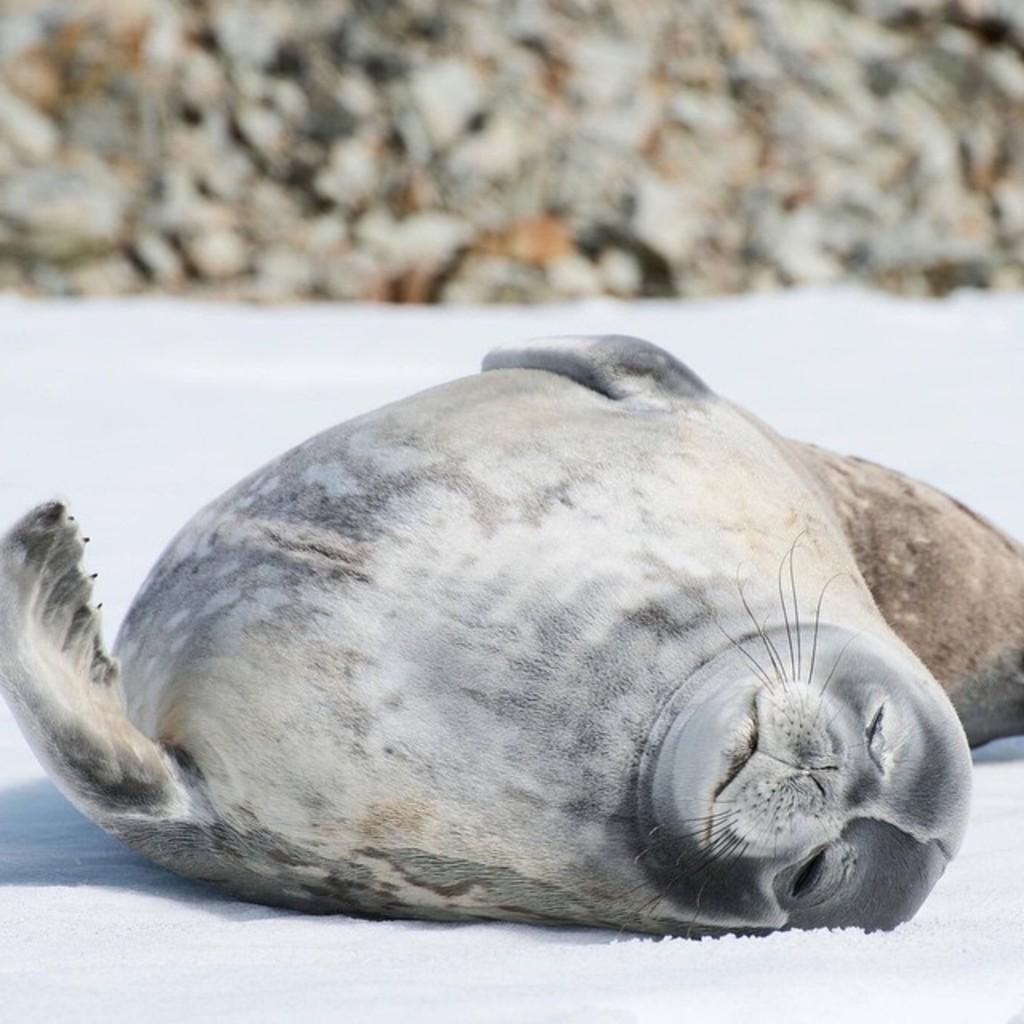How would you summarize this image in a sentence or two? In this image we can see black color seal is sleeping on the snow ground. 